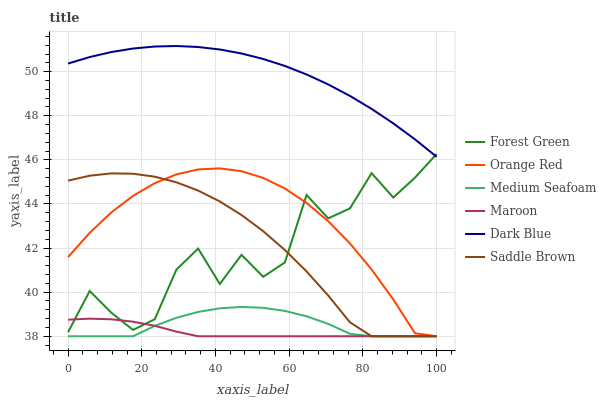Does Orange Red have the minimum area under the curve?
Answer yes or no. No. Does Orange Red have the maximum area under the curve?
Answer yes or no. No. Is Orange Red the smoothest?
Answer yes or no. No. Is Orange Red the roughest?
Answer yes or no. No. Does Dark Blue have the lowest value?
Answer yes or no. No. Does Orange Red have the highest value?
Answer yes or no. No. Is Orange Red less than Dark Blue?
Answer yes or no. Yes. Is Dark Blue greater than Maroon?
Answer yes or no. Yes. Does Orange Red intersect Dark Blue?
Answer yes or no. No. 